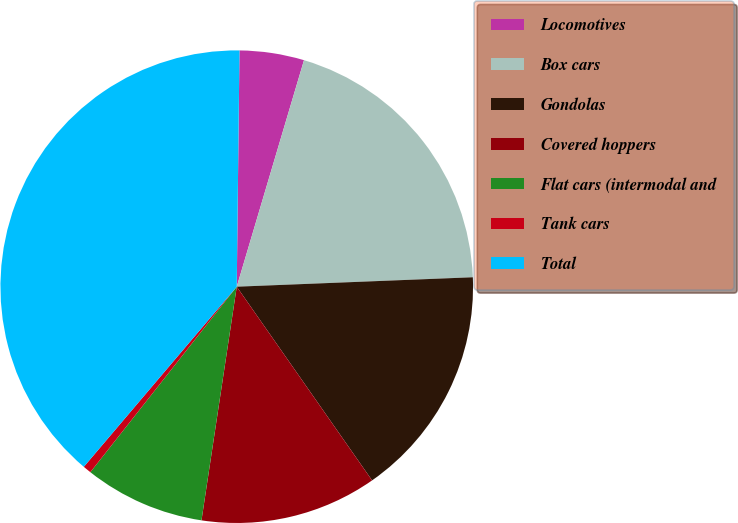<chart> <loc_0><loc_0><loc_500><loc_500><pie_chart><fcel>Locomotives<fcel>Box cars<fcel>Gondolas<fcel>Covered hoppers<fcel>Flat cars (intermodal and<fcel>Tank cars<fcel>Total<nl><fcel>4.41%<fcel>19.77%<fcel>15.93%<fcel>12.09%<fcel>8.25%<fcel>0.57%<fcel>38.98%<nl></chart> 